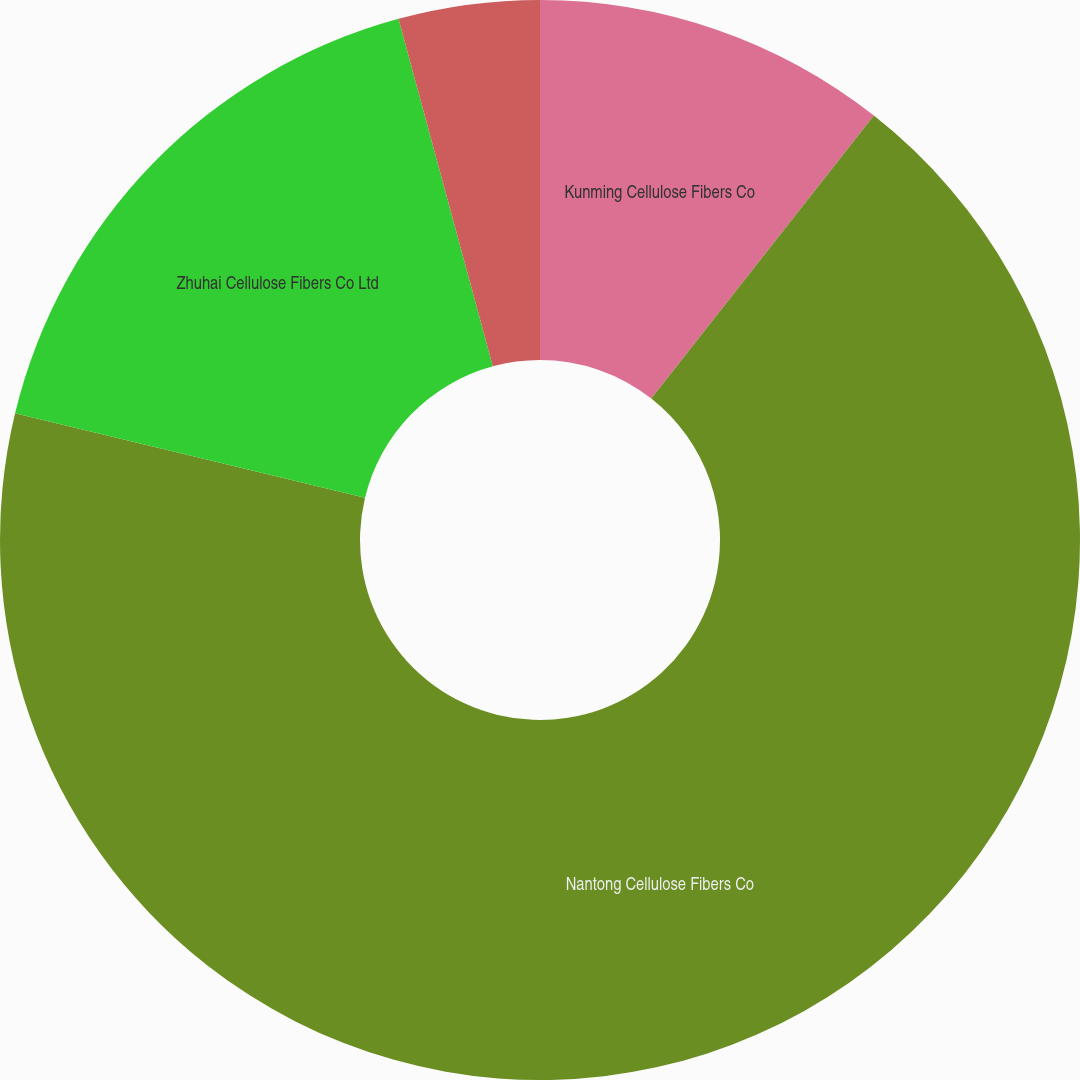<chart> <loc_0><loc_0><loc_500><loc_500><pie_chart><fcel>Kunming Cellulose Fibers Co<fcel>Nantong Cellulose Fibers Co<fcel>Zhuhai Cellulose Fibers Co Ltd<fcel>InfraServ GmbH & Co Wiesbaden<nl><fcel>10.61%<fcel>68.17%<fcel>17.01%<fcel>4.22%<nl></chart> 